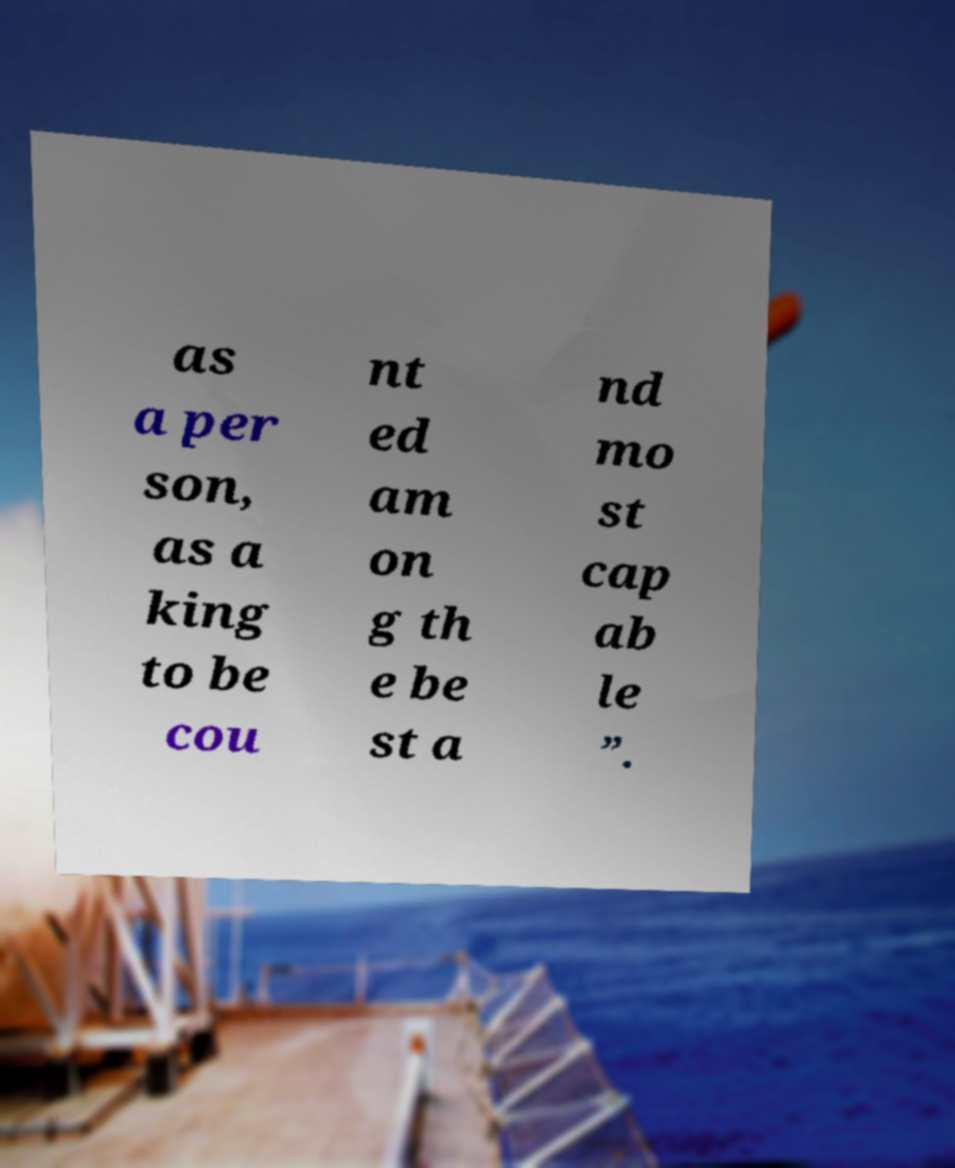Please read and relay the text visible in this image. What does it say? as a per son, as a king to be cou nt ed am on g th e be st a nd mo st cap ab le ”. 